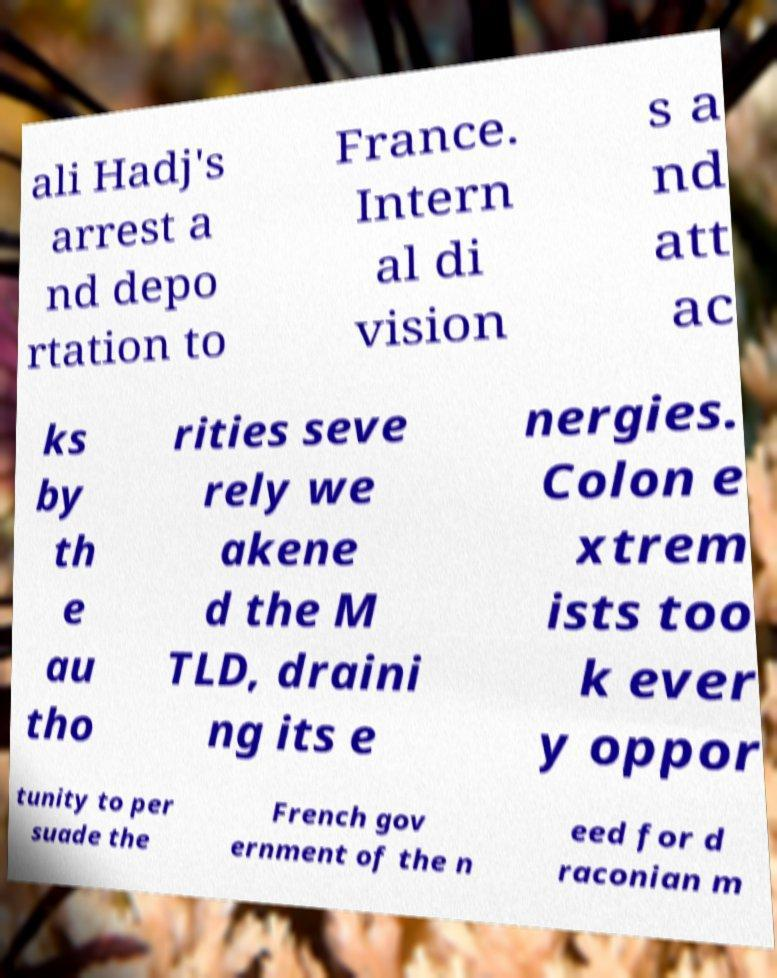Please identify and transcribe the text found in this image. ali Hadj's arrest a nd depo rtation to France. Intern al di vision s a nd att ac ks by th e au tho rities seve rely we akene d the M TLD, draini ng its e nergies. Colon e xtrem ists too k ever y oppor tunity to per suade the French gov ernment of the n eed for d raconian m 